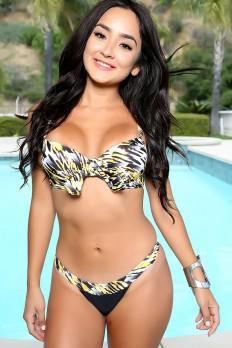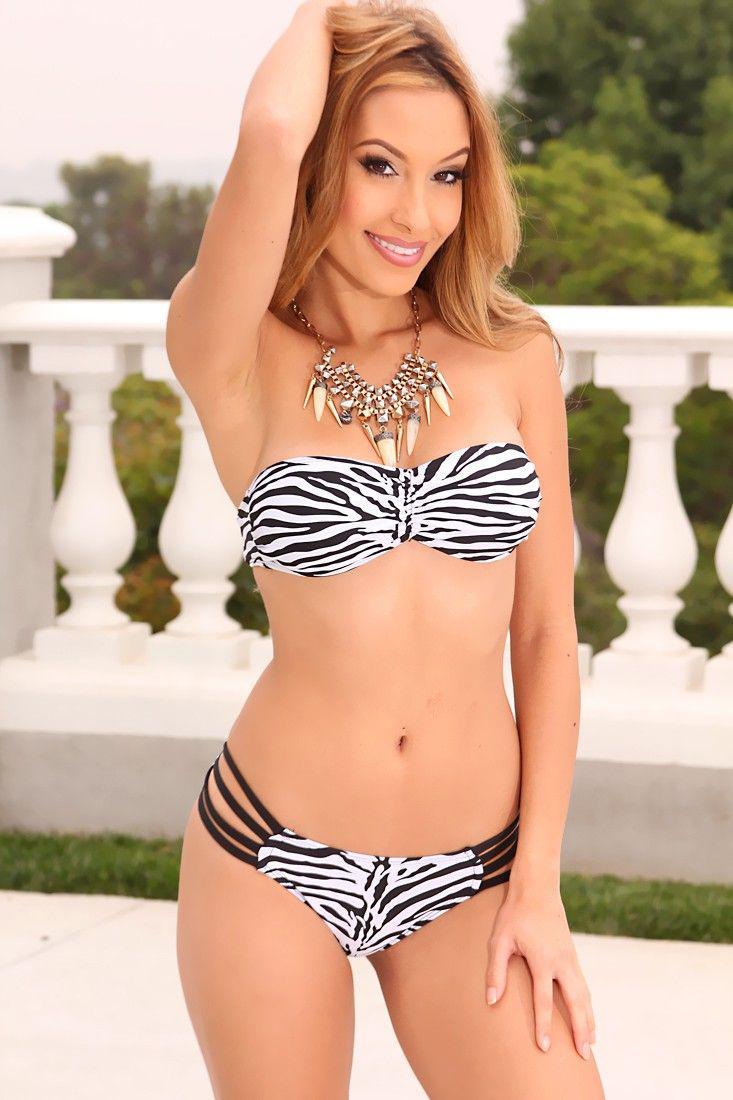The first image is the image on the left, the second image is the image on the right. For the images shown, is this caption "The swimsuit in the image on the left has a floral print." true? Answer yes or no. No. 